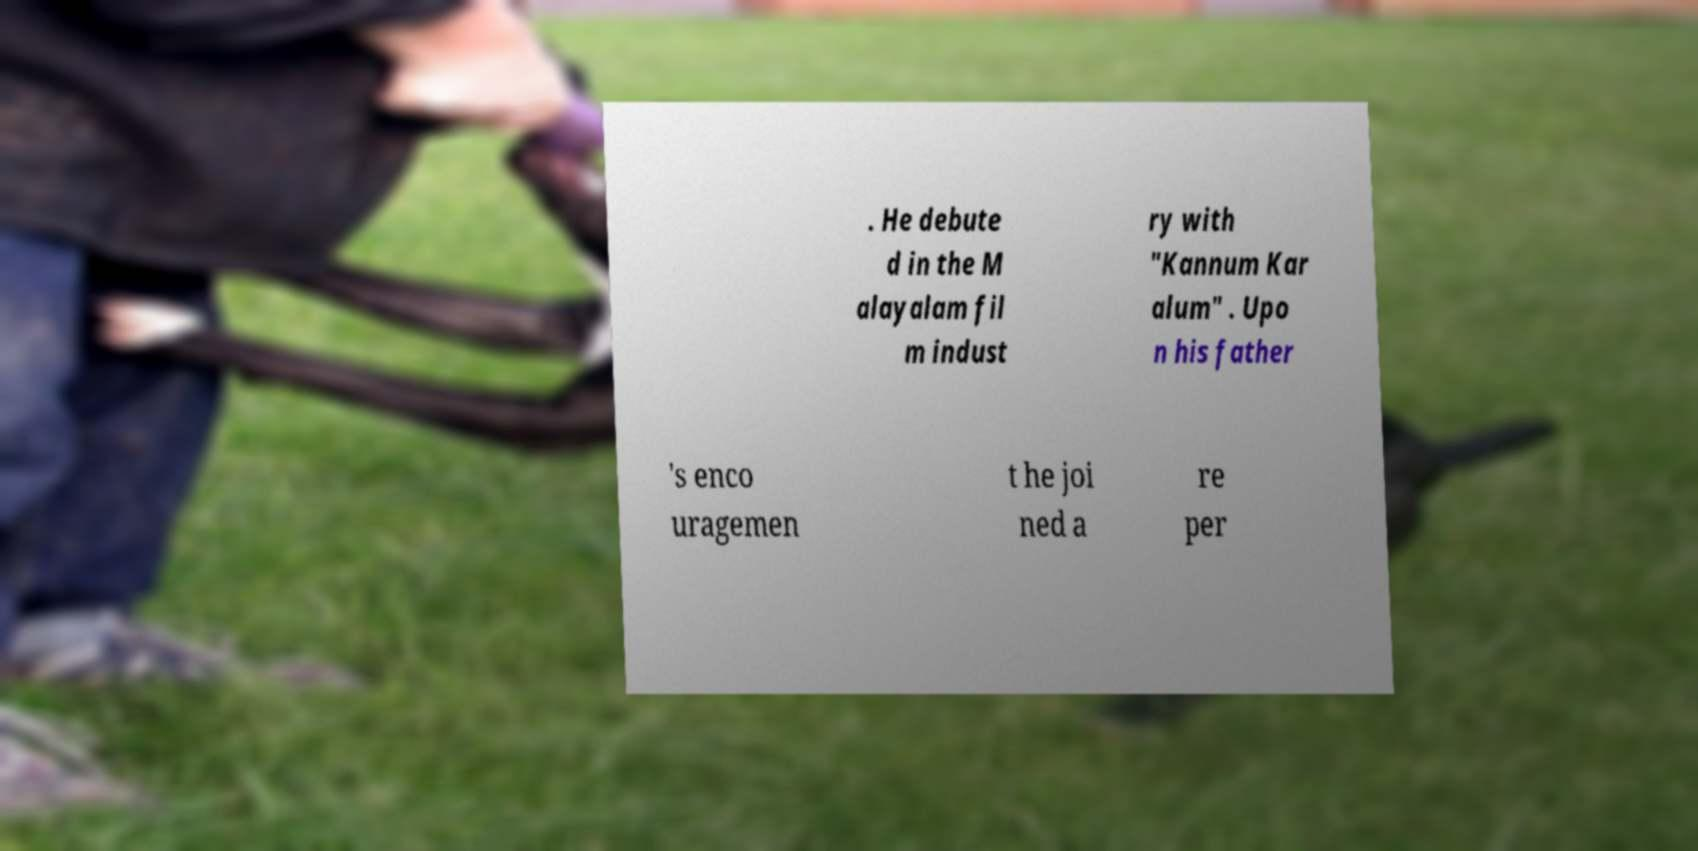Can you read and provide the text displayed in the image?This photo seems to have some interesting text. Can you extract and type it out for me? . He debute d in the M alayalam fil m indust ry with "Kannum Kar alum" . Upo n his father 's enco uragemen t he joi ned a re per 